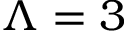Convert formula to latex. <formula><loc_0><loc_0><loc_500><loc_500>\Lambda = 3</formula> 